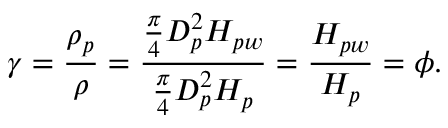Convert formula to latex. <formula><loc_0><loc_0><loc_500><loc_500>\gamma = \frac { \rho _ { p } } { \rho } = \frac { \frac { \pi } { 4 } D _ { p } ^ { 2 } H _ { p w } } { \frac { \pi } { 4 } D _ { p } ^ { 2 } H _ { p } } = \frac { H _ { p w } } { H _ { p } } = \phi .</formula> 